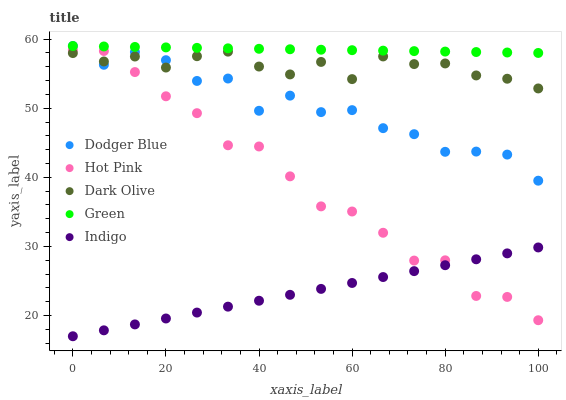Does Indigo have the minimum area under the curve?
Answer yes or no. Yes. Does Green have the maximum area under the curve?
Answer yes or no. Yes. Does Hot Pink have the minimum area under the curve?
Answer yes or no. No. Does Hot Pink have the maximum area under the curve?
Answer yes or no. No. Is Indigo the smoothest?
Answer yes or no. Yes. Is Dodger Blue the roughest?
Answer yes or no. Yes. Is Green the smoothest?
Answer yes or no. No. Is Green the roughest?
Answer yes or no. No. Does Indigo have the lowest value?
Answer yes or no. Yes. Does Hot Pink have the lowest value?
Answer yes or no. No. Does Dodger Blue have the highest value?
Answer yes or no. Yes. Does Hot Pink have the highest value?
Answer yes or no. No. Is Indigo less than Dark Olive?
Answer yes or no. Yes. Is Green greater than Hot Pink?
Answer yes or no. Yes. Does Hot Pink intersect Dodger Blue?
Answer yes or no. Yes. Is Hot Pink less than Dodger Blue?
Answer yes or no. No. Is Hot Pink greater than Dodger Blue?
Answer yes or no. No. Does Indigo intersect Dark Olive?
Answer yes or no. No. 